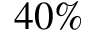<formula> <loc_0><loc_0><loc_500><loc_500>4 0 \%</formula> 